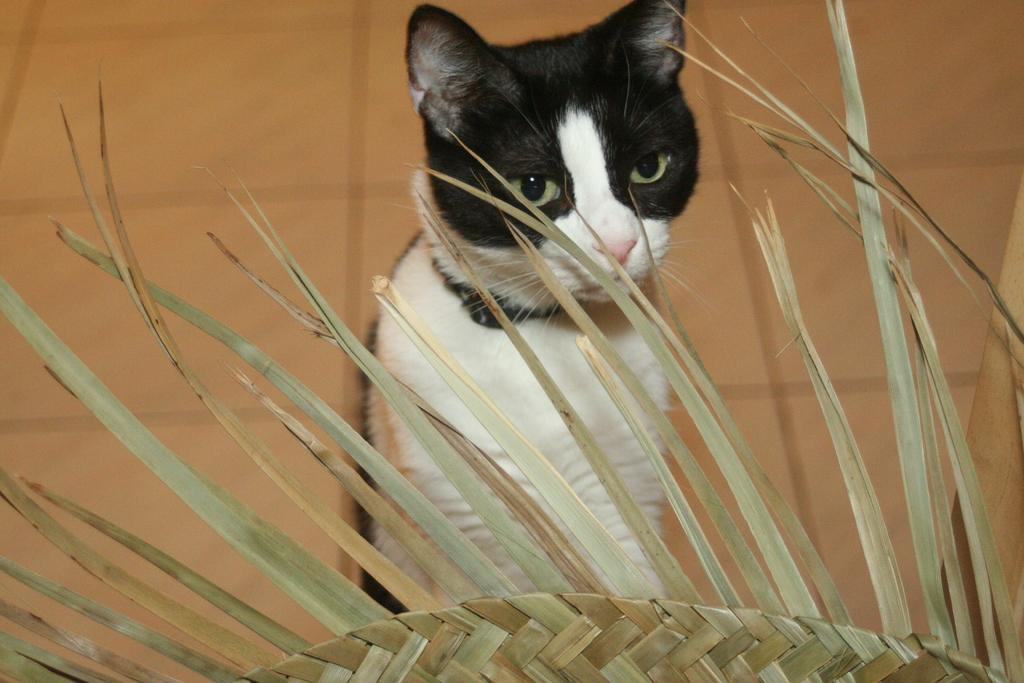What type of animal is present in the image? There is a cat in the image. Can you describe the color pattern of the cat? The cat has a white and black color pattern. What is in front of the cat in the image? There is an object made up of leaves in front of the cat. What type of quiver can be seen in the image? There is no quiver present in the image; it features a cat and an object made up of leaves. What type of glass is being used by the cat in the image? There is no glass present in the image; it features a cat and an object made up of leaves. 